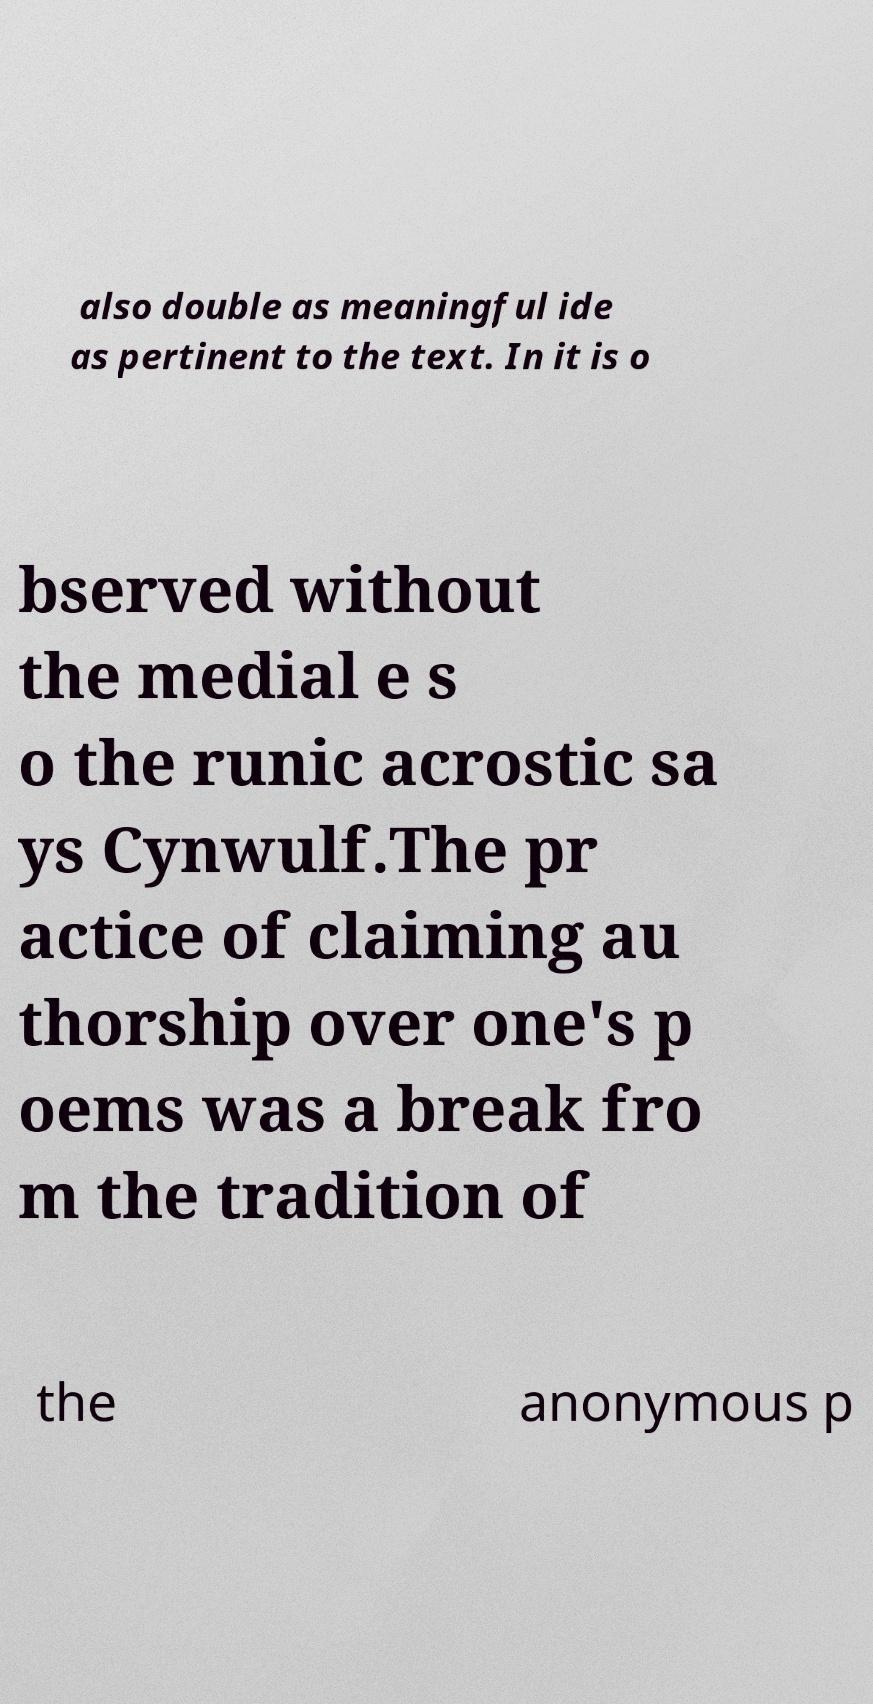Could you assist in decoding the text presented in this image and type it out clearly? also double as meaningful ide as pertinent to the text. In it is o bserved without the medial e s o the runic acrostic sa ys Cynwulf.The pr actice of claiming au thorship over one's p oems was a break fro m the tradition of the anonymous p 